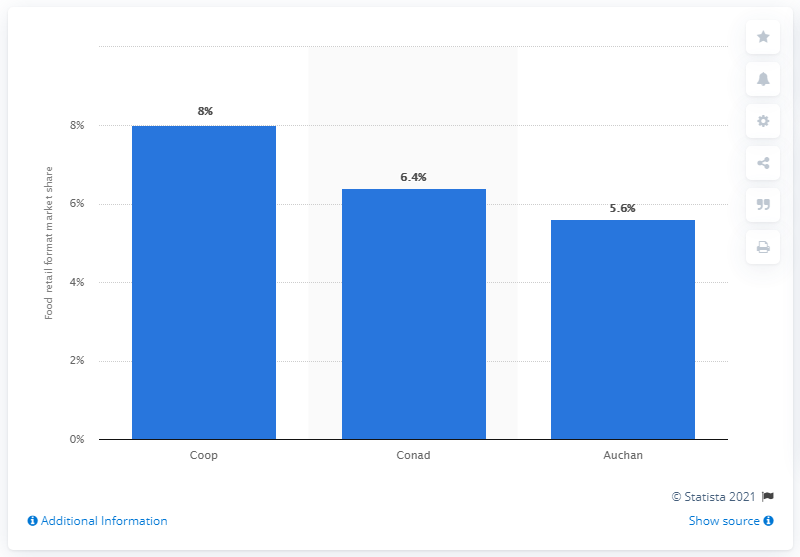Draw attention to some important aspects in this diagram. In 2013, Coop was the market leader. 